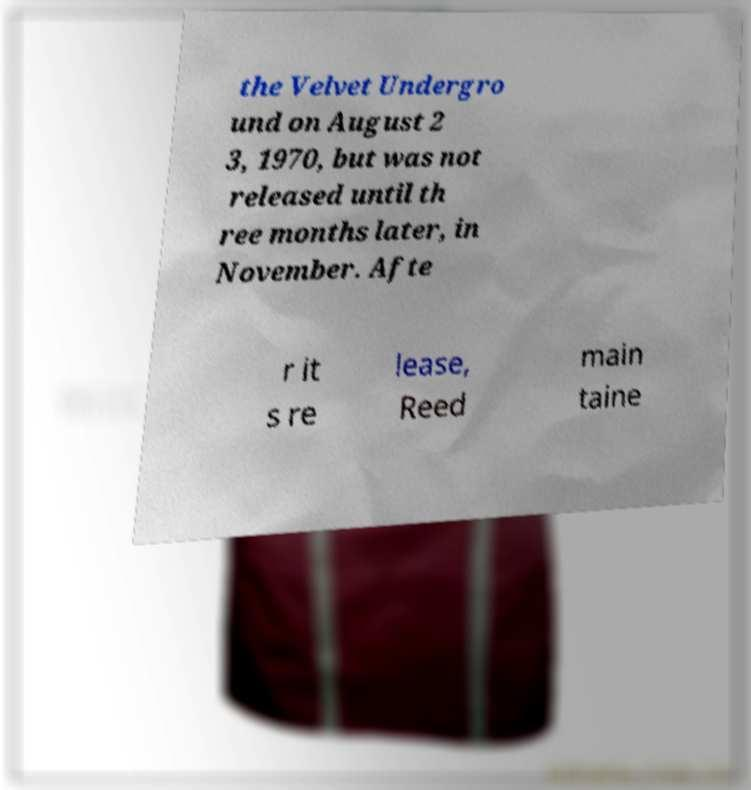There's text embedded in this image that I need extracted. Can you transcribe it verbatim? the Velvet Undergro und on August 2 3, 1970, but was not released until th ree months later, in November. Afte r it s re lease, Reed main taine 